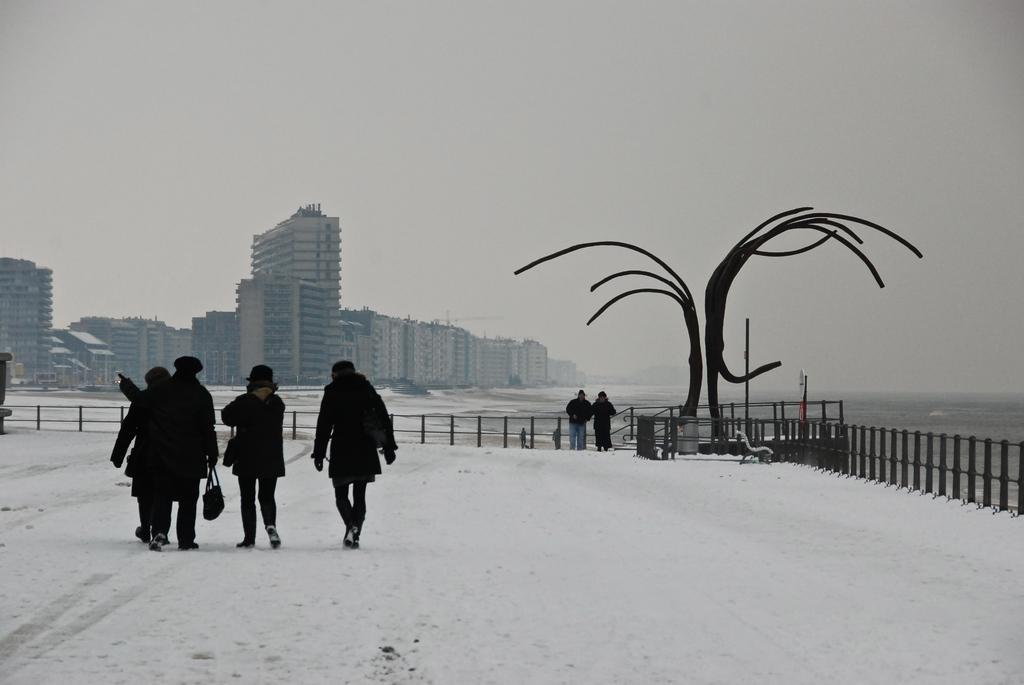Could you give a brief overview of what you see in this image? In this image I can see ground full of snow and on it I can see few people are standing. I can see all of them are wearing jackets and few of them all carrying bags. In the background I can see number of buildings and here I can see a bench. 